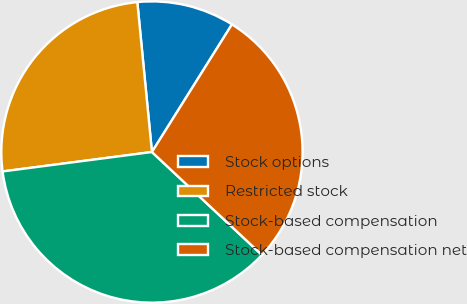Convert chart to OTSL. <chart><loc_0><loc_0><loc_500><loc_500><pie_chart><fcel>Stock options<fcel>Restricted stock<fcel>Stock-based compensation<fcel>Stock-based compensation net<nl><fcel>10.46%<fcel>25.51%<fcel>35.97%<fcel>28.06%<nl></chart> 